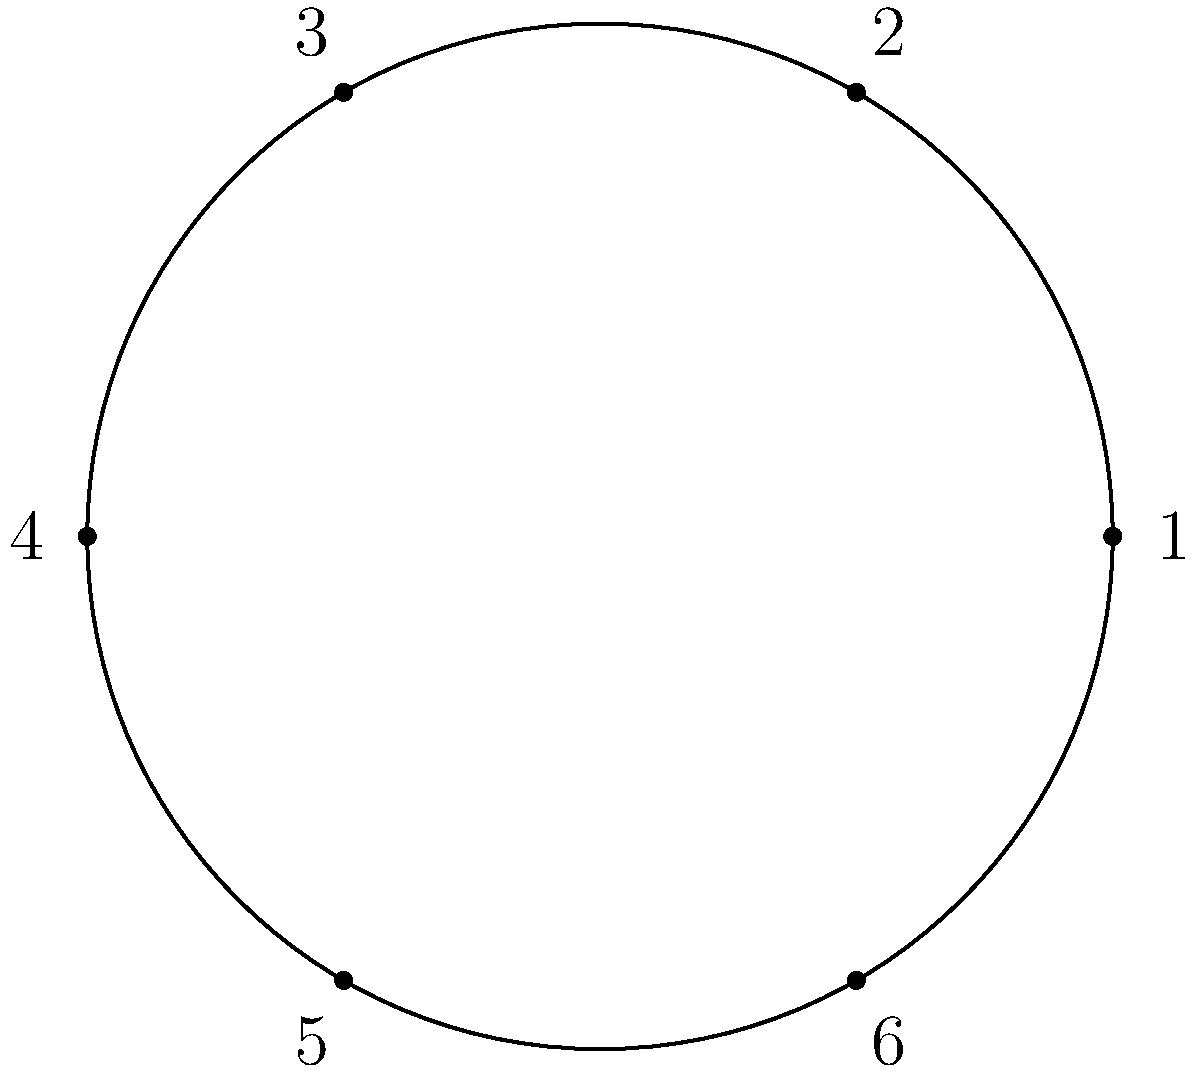Consider a circular arrangement of six global spice blends, numbered 1 to 6 as shown in the diagram. This arrangement forms a cyclic group under rotation. If we apply the group operation (rotation) twice, moving from spice blend 1 to spice blend 3, what is the order of this group element? Let's approach this step-by-step:

1) In a cyclic group of order 6, we have six elements that can be generated by repeated application of a single operation (in this case, rotation).

2) The group operation here is rotation, and we're told that applying it twice moves us from position 1 to position 3.

3) This means that a single application of this operation rotates the circle by 2 positions clockwise.

4) To find the order of this element, we need to determine how many times we need to apply this operation to get back to the starting position.

5) Let's track the positions:
   - Start at 1
   - After 1 application: 3
   - After 2 applications: 5
   - After 3 applications: 1 (back to the start)

6) We see that it takes 3 applications of this operation to return to the starting position.

7) In group theory, the order of an element is the smallest positive integer $n$ such that $g^n = e$, where $g$ is the group element and $e$ is the identity element.

8) Therefore, the order of this group element is 3.
Answer: 3 